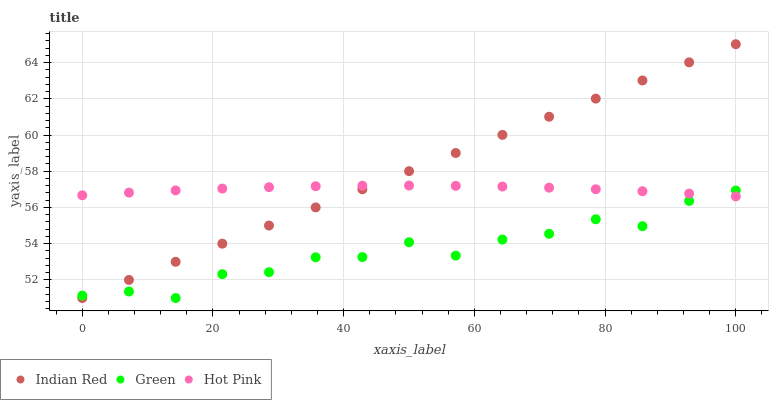Does Green have the minimum area under the curve?
Answer yes or no. Yes. Does Indian Red have the maximum area under the curve?
Answer yes or no. Yes. Does Indian Red have the minimum area under the curve?
Answer yes or no. No. Does Green have the maximum area under the curve?
Answer yes or no. No. Is Indian Red the smoothest?
Answer yes or no. Yes. Is Green the roughest?
Answer yes or no. Yes. Is Green the smoothest?
Answer yes or no. No. Is Indian Red the roughest?
Answer yes or no. No. Does Green have the lowest value?
Answer yes or no. Yes. Does Indian Red have the highest value?
Answer yes or no. Yes. Does Green have the highest value?
Answer yes or no. No. Does Indian Red intersect Hot Pink?
Answer yes or no. Yes. Is Indian Red less than Hot Pink?
Answer yes or no. No. Is Indian Red greater than Hot Pink?
Answer yes or no. No. 